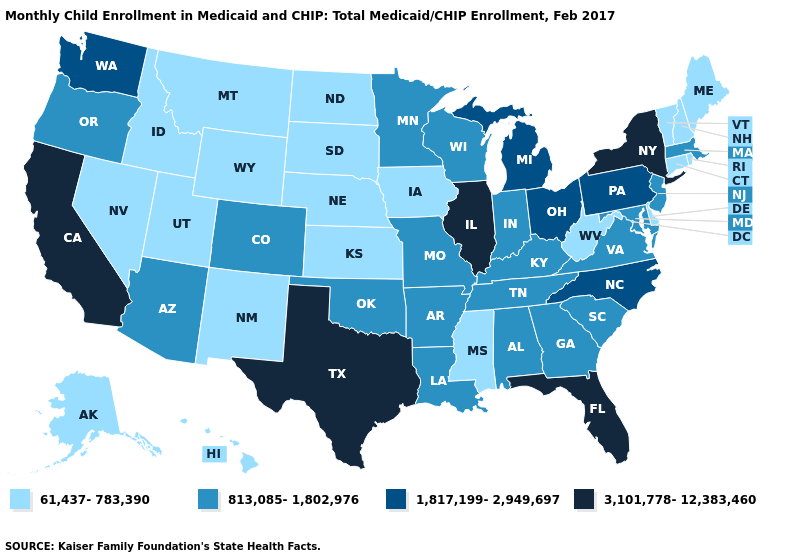Name the states that have a value in the range 813,085-1,802,976?
Concise answer only. Alabama, Arizona, Arkansas, Colorado, Georgia, Indiana, Kentucky, Louisiana, Maryland, Massachusetts, Minnesota, Missouri, New Jersey, Oklahoma, Oregon, South Carolina, Tennessee, Virginia, Wisconsin. Does Illinois have the highest value in the USA?
Concise answer only. Yes. Does Ohio have the same value as Wisconsin?
Give a very brief answer. No. What is the lowest value in the West?
Concise answer only. 61,437-783,390. What is the lowest value in the USA?
Quick response, please. 61,437-783,390. What is the lowest value in the West?
Write a very short answer. 61,437-783,390. Does Connecticut have the same value as Minnesota?
Keep it brief. No. Which states have the lowest value in the Northeast?
Quick response, please. Connecticut, Maine, New Hampshire, Rhode Island, Vermont. Does the map have missing data?
Concise answer only. No. Does Pennsylvania have a lower value than Ohio?
Concise answer only. No. Does Montana have a lower value than Nebraska?
Answer briefly. No. Which states hav the highest value in the South?
Concise answer only. Florida, Texas. Does Nevada have the highest value in the West?
Write a very short answer. No. Does Oregon have the lowest value in the West?
Short answer required. No. What is the lowest value in states that border South Carolina?
Give a very brief answer. 813,085-1,802,976. 